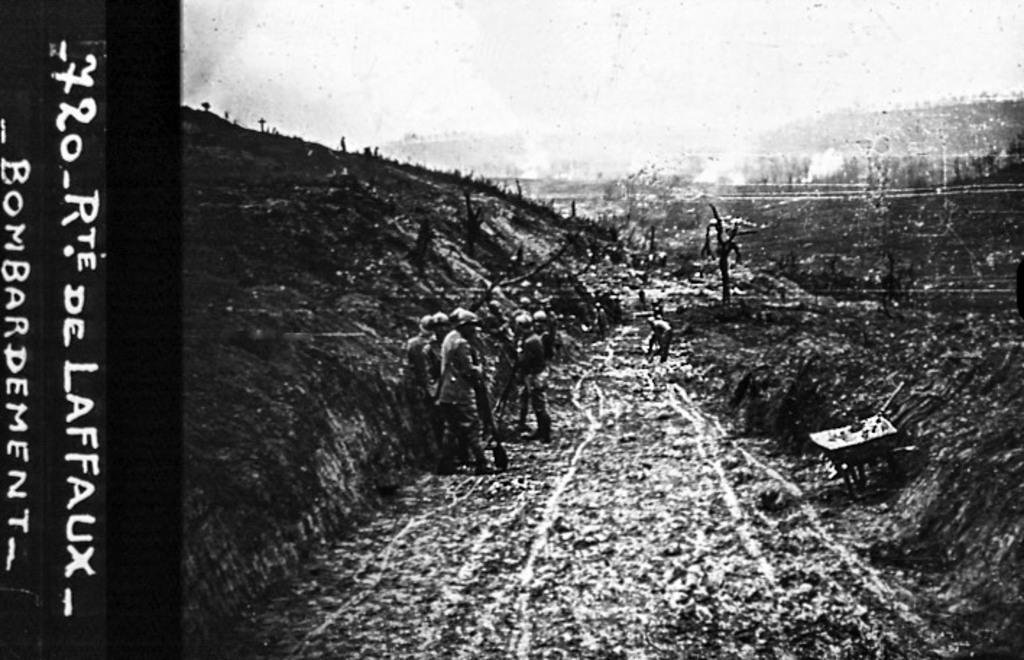Provide a one-sentence caption for the provided image. A black and white photograph featuring the bombardment of Rte. de Laffaux. 